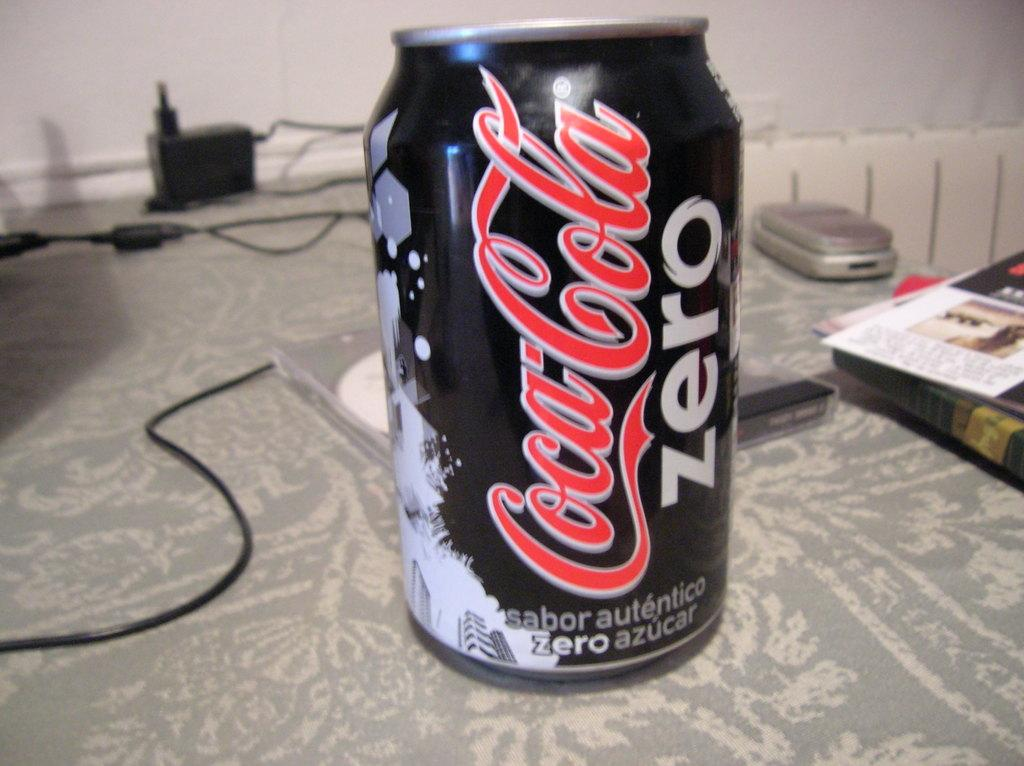<image>
Write a terse but informative summary of the picture. A can of Coca-cola zero on a patterned gray tablecloth. 